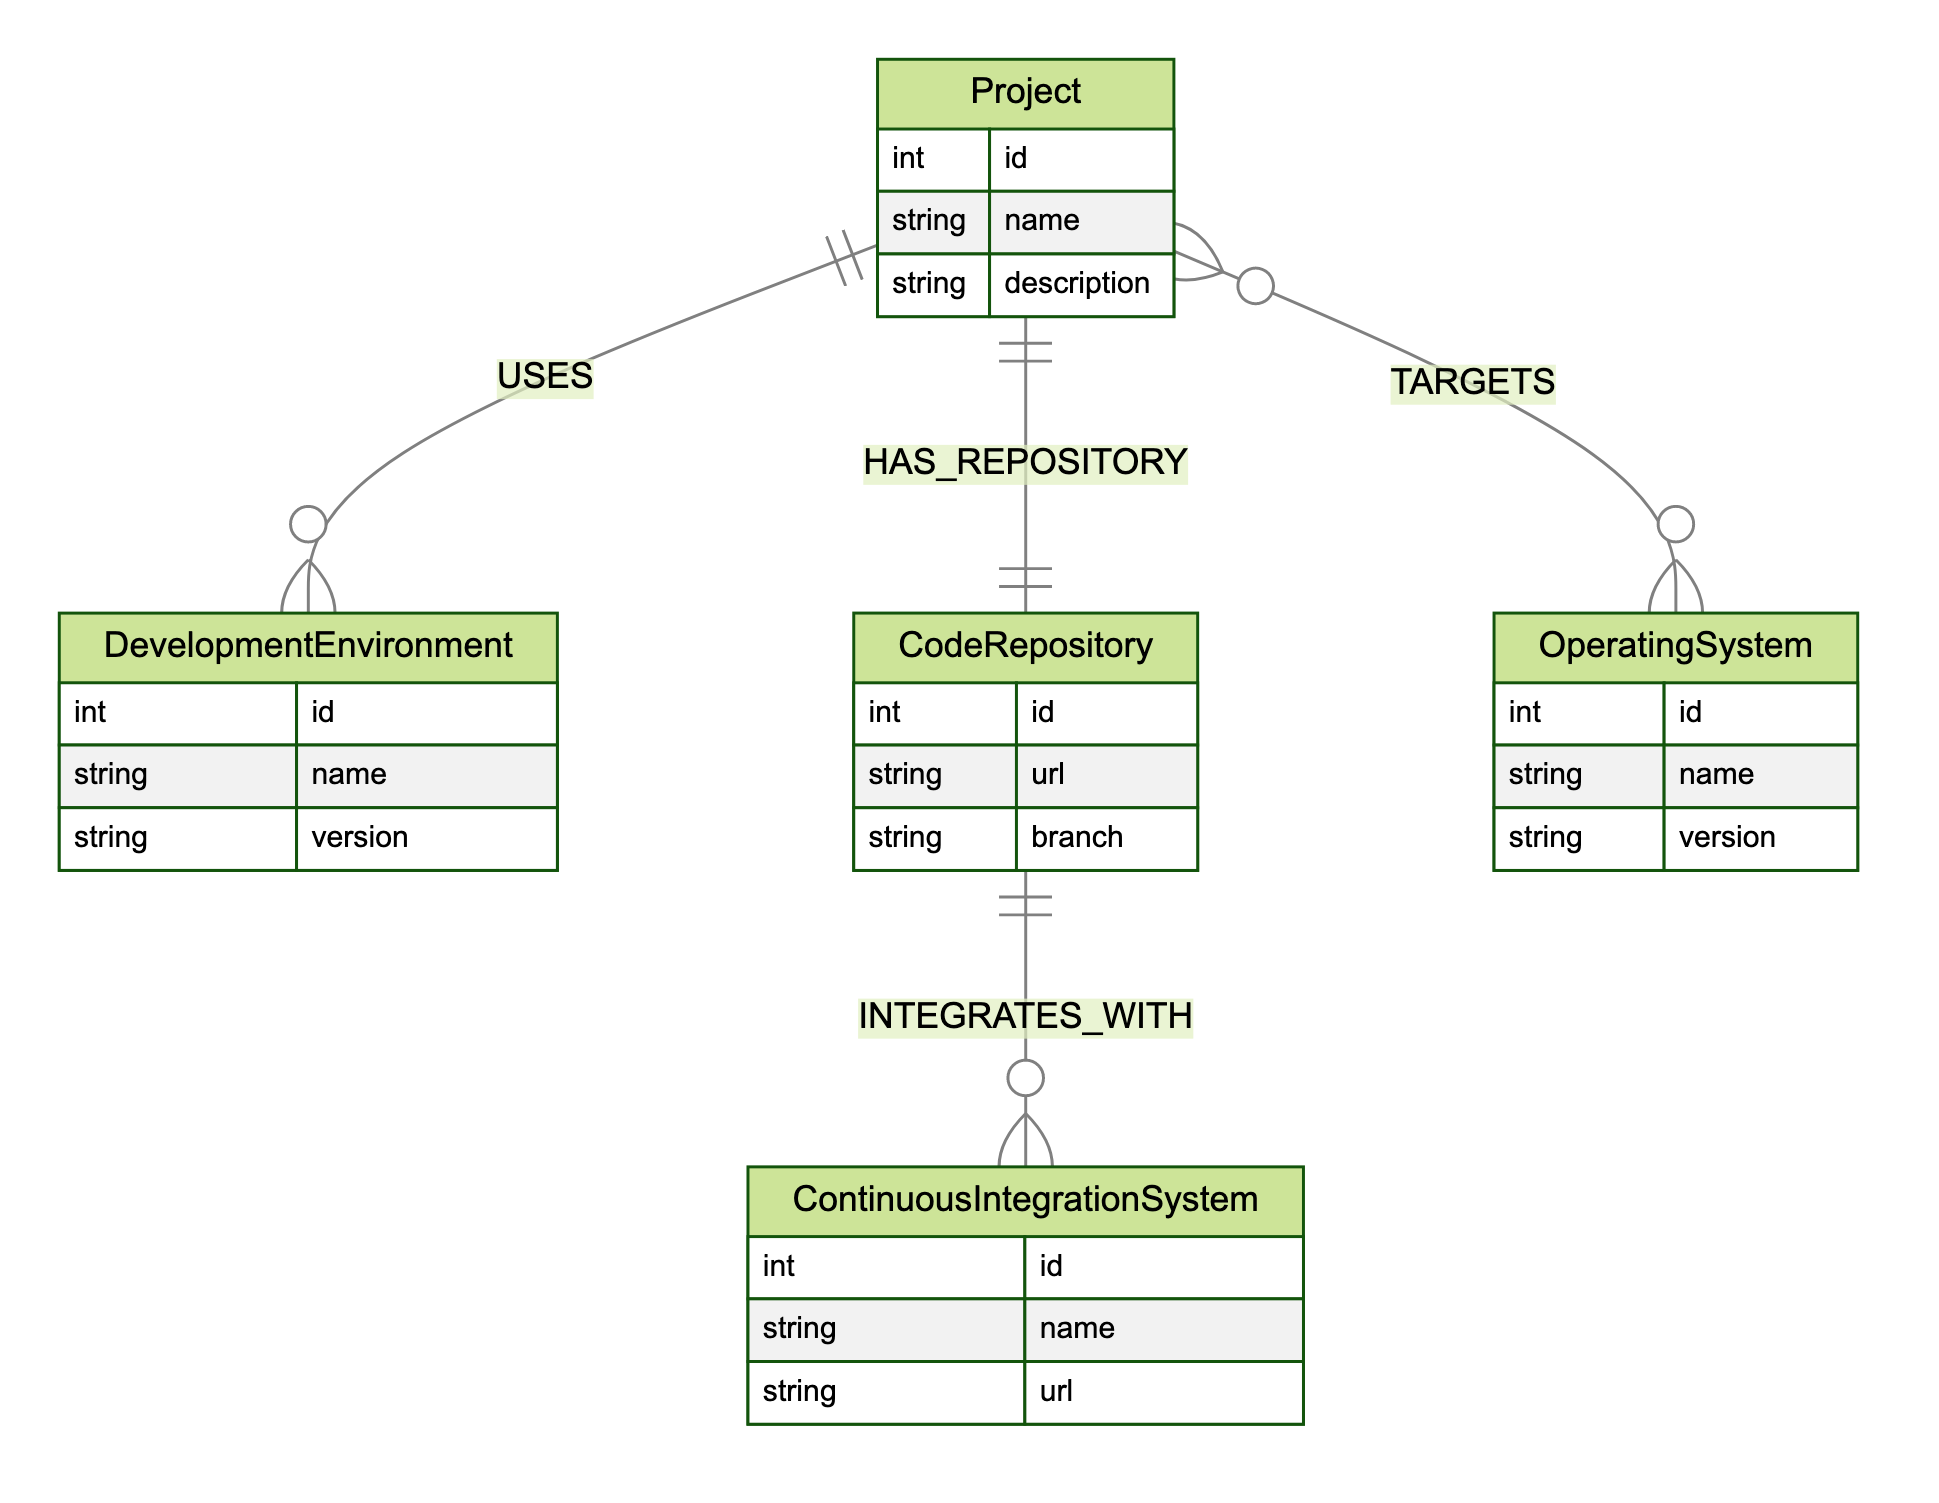What is the relationship between Project and DevelopmentEnvironment? The diagram indicates that there is a relationship named "USES" between the "Project" and "DevelopmentEnvironment" entities, meaning a project utilizes a specific development environment.
Answer: USES How many attributes does the CodeRepository entity have? By inspecting the "CodeRepository" entity in the diagram, we see that it has three attributes listed: id, url, and branch. Therefore, the total count of attributes is three.
Answer: 3 Which entity integrates with ContinuousIntegrationSystem? The diagram shows a relationship named "INTEGRATES_WITH" between "CodeRepository" and "ContinuousIntegrationSystem," indicating that a code repository integrates with a continuous integration system.
Answer: CodeRepository What does the Project targets? The diagram indicates a relationship labeled "TARGETS," linking the "Project" to "OperatingSystem," meaning that a project is aimed at one or more operating systems.
Answer: OperatingSystem How many entities are there in the diagram? Upon reviewing the entities outlined in the diagram, we identify five entities: Project, DevelopmentEnvironment, CodeRepository, ContinuousIntegrationSystem, and OperatingSystem. Therefore, the total number of entities is five.
Answer: 5 Which two entities share the HAS_REPOSITORY relationship? The "HAS_REPOSITORY" relationship is depicted in the diagram connecting "Project" with "CodeRepository," indicating that a project has one or more code repositories associated with it.
Answer: Project, CodeRepository In the context of the diagram, what is the purpose of the DevelopmentEnvironment entity? Looking at the diagram, the "DevelopmentEnvironment" entity represents the environments used by projects, which suggests that this entity is important for specifying the context in which the project is being developed.
Answer: Used for projects How many relationships are defined in the diagram? By analyzing the relationships listed, we can see four connections defined: USES, HAS_REPOSITORY, INTEGRATES_WITH, and TARGETS. Thus, the total count of relationships is four.
Answer: 4 What is the ID attribute of the OperatingSystem entity? The "OperatingSystem" entity includes an attribute "id," which is used to uniquely identify each operating system; however, the specific ID value is not provided in the diagram itself. The attribute's presence confirms its role as a unique identifier.
Answer: id 